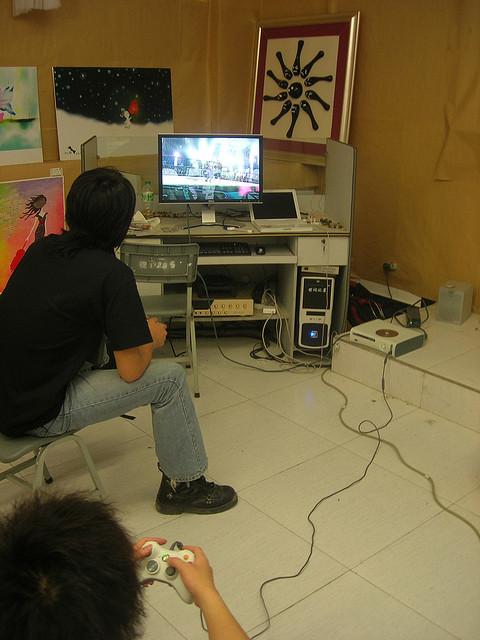What type of game system is the boy playing?
Concise answer only. Playstation. Is the floor hard?
Quick response, please. Yes. What gaming platform is he using?
Quick response, please. Xbox. What brand is the video game?
Be succinct. Xbox. What game is being played?
Answer briefly. Video game. What is the game the man is playing?
Short answer required. Video game. What type of flooring is in the room?
Short answer required. Tile. Are both people in the picture seated?
Concise answer only. Yes. What console are these women playing?
Short answer required. Xbox. What game system is she using?
Concise answer only. Xbox. What brand of gaming system is the girl playing?
Give a very brief answer. Xbox. 